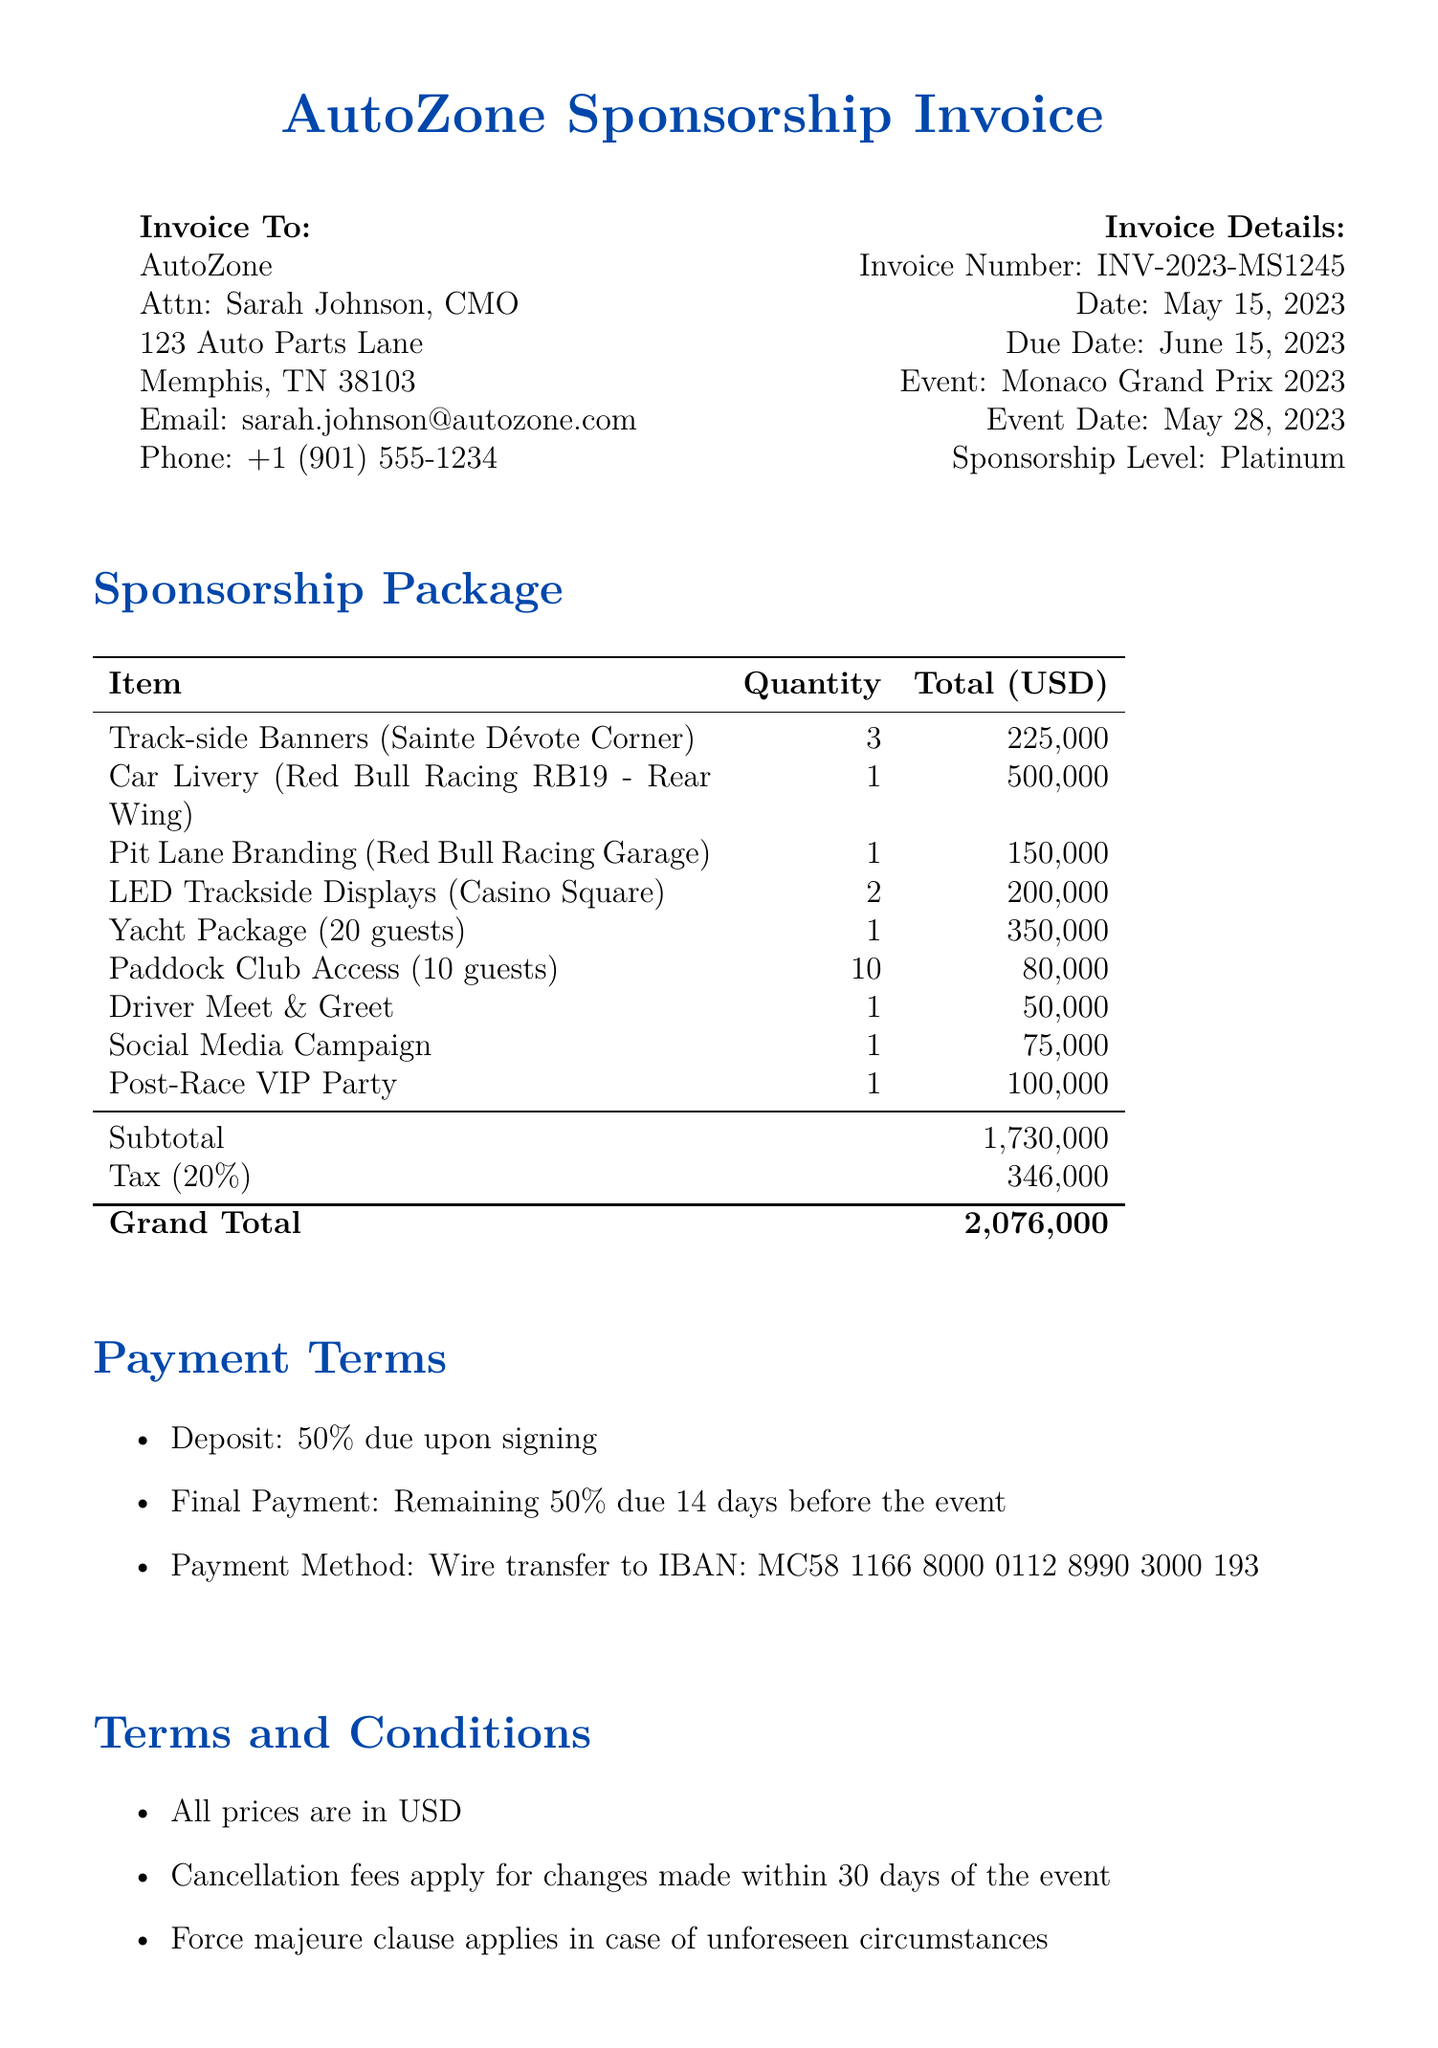What is the invoice number? The invoice number is mentioned in the document, which is used for reference and tracking.
Answer: INV-2023-MS1245 What is the date of the invoice? The date indicates when the invoice was issued and is clearly stated in the document.
Answer: May 15, 2023 How many Track-side Banners are included? The quantity of Track-side Banners is listed in the document under advertising placements.
Answer: 3 What is the total for the Yacht Package? The total cost for the Yacht Package is specified in the VIP hospitality packages section of the document.
Answer: 350,000 What percentage is the tax applied to the subtotal? The document states the tax percentage applied to the subtotal, providing clarity on the calculations.
Answer: 20% How many guests can be accommodated in the Yacht Package? The document provides a description of the Yacht Package, mentioning the guest capacity.
Answer: 20 guests What is the payment method outlined in the document? The payment method details how the payment should be completed, which is essentially a wire transfer.
Answer: Wire transfer to IBAN What does the subtotal amount to? The subtotal is listed in the document as a breakdown of costs before tax.
Answer: 1,730,000 What are the consequences of cancellation mentioned? The document specifies the implications of cancellation related to the event timeline.
Answer: Cancellation fees apply for changes made within 30 days of the event 